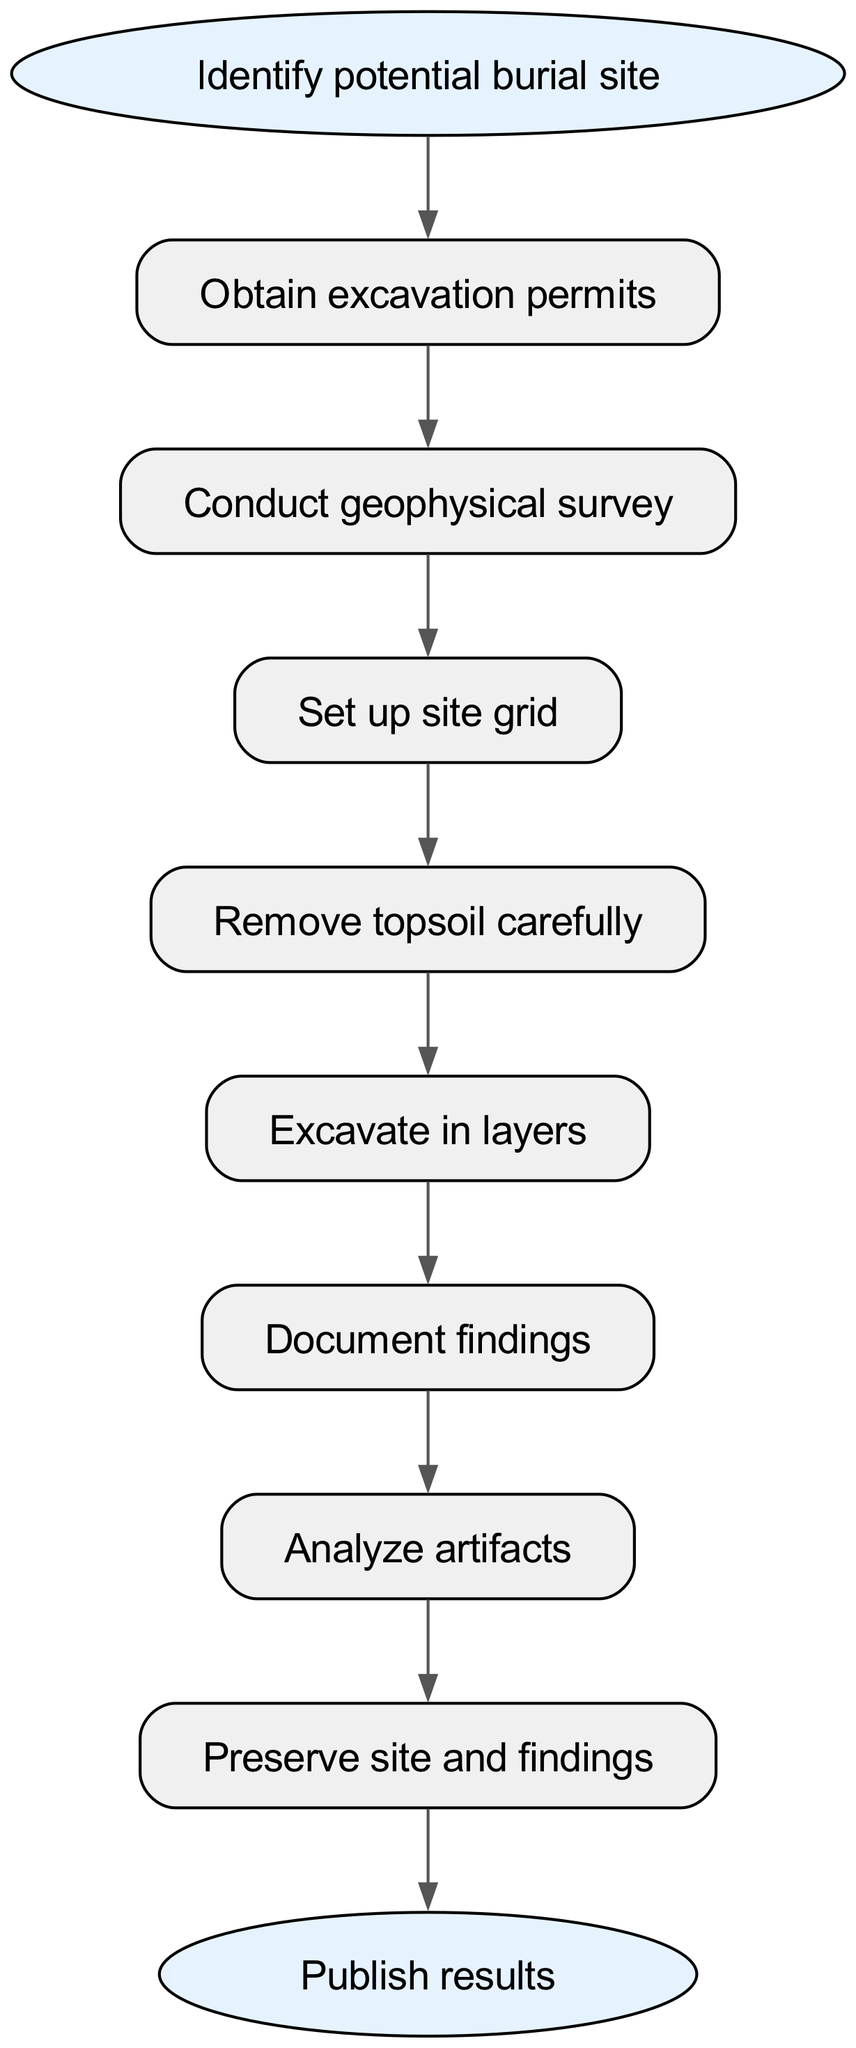What is the first step in the excavation process? The diagram starts with the node labeled "Identify potential burial site," indicating this is the initial action before proceeding to obtain permits.
Answer: Identify potential burial site How many steps are involved in the excavation process? By counting the nodes between the starting and ending points in the diagram, we find there are eight steps in total that are part of the excavation process.
Answer: Eight What follows after conducting the geophysical survey? According to the diagram, after completing the "Conduct geophysical survey," the next step is "Set up site grid," illustrating the order of operations in the process.
Answer: Set up site grid What is the final action in the excavation process? The last node before reaching the end is labeled "Publish results," which signifies the final action taken after all excavation work and documentation is complete.
Answer: Publish results How does the removal of topsoil relate to excavation in layers? The diagram indicates a direct connection from "Remove topsoil carefully" to "Excavate in layers," showing that removing the topsoil is a prerequisite for the more detailed excavation that follows.
Answer: It precedes excavation in layers Which step requires preserving both the site and findings? The step labeled "Preserve site and findings" directly addresses the importance of protecting the integrity of the excavation site as well as the artifacts discovered during the process.
Answer: Preserve site and findings What is the purpose of analyzing artifacts in the excavation process? Analyzing artifacts is an essential step after documenting findings, serving to provide insights into the history and significance of the items uncovered in the burial site.
Answer: Gain insights into history What do you do after documenting findings? Following the "Document findings" step according to the flow, the process continues with "Analyze artifacts," indicating that documentation leads directly to analysis of the uncovered materials.
Answer: Analyze artifacts Which step comes right after removing topsoil? The process moves from "Remove topsoil carefully" directly to "Excavate in layers," showing that once the topsoil is removed, excavation focuses on the underlying layers.
Answer: Excavate in layers 